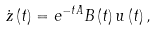Convert formula to latex. <formula><loc_0><loc_0><loc_500><loc_500>\dot { z } \left ( t \right ) = e ^ { - t A } B \left ( t \right ) u \left ( t \right ) ,</formula> 